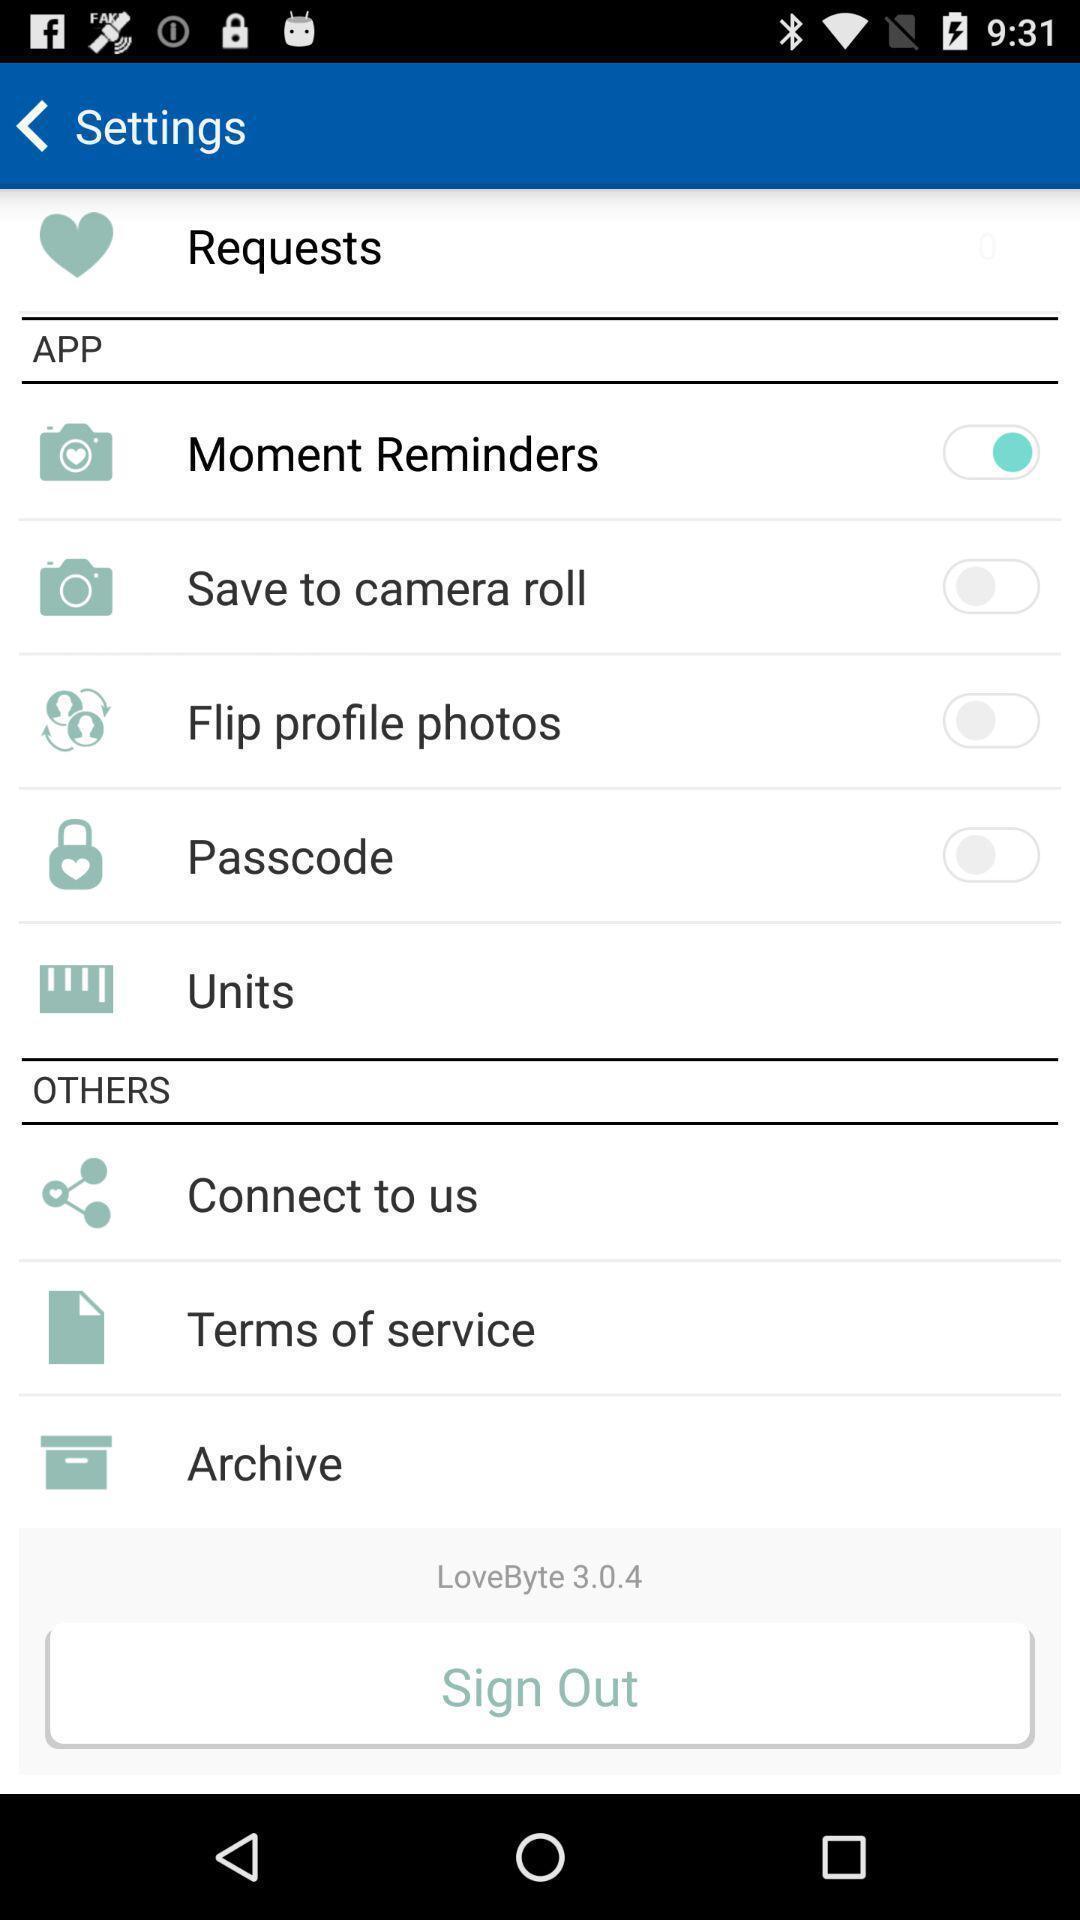Summarize the information in this screenshot. Settings page. 